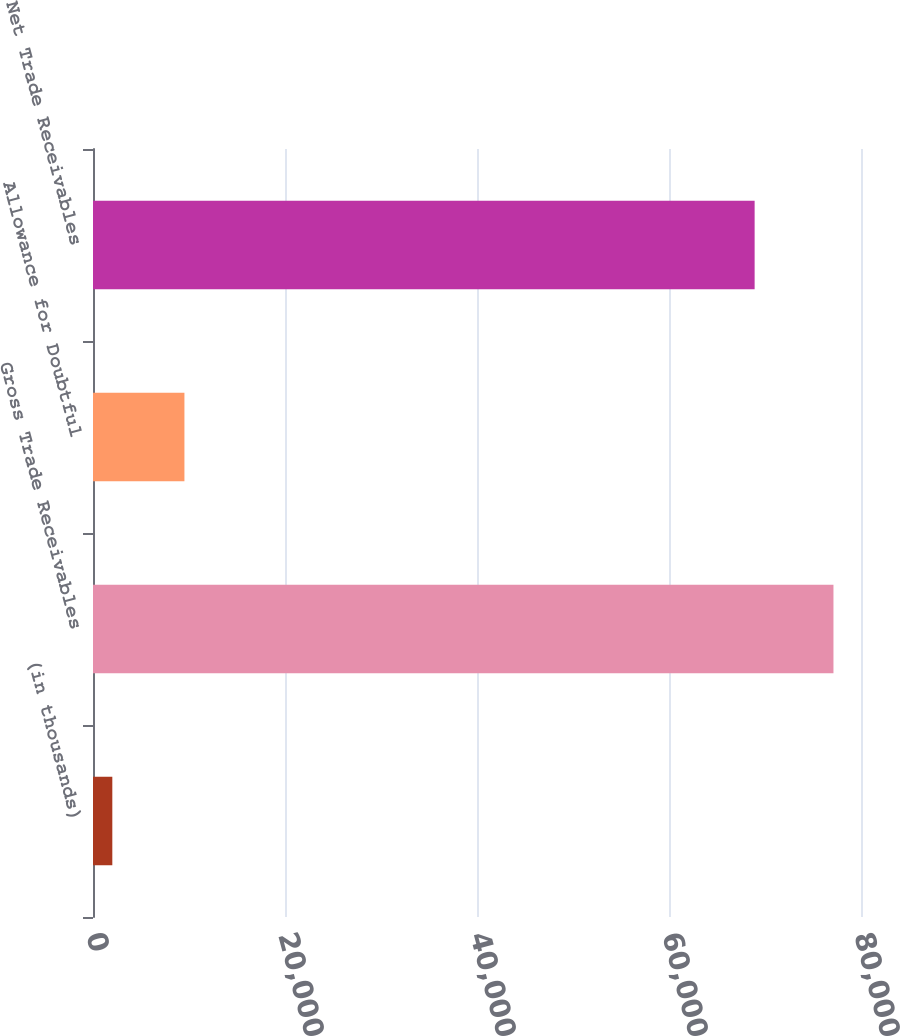<chart> <loc_0><loc_0><loc_500><loc_500><bar_chart><fcel>(in thousands)<fcel>Gross Trade Receivables<fcel>Allowance for Doubtful<fcel>Net Trade Receivables<nl><fcel>2012<fcel>77131<fcel>9523.9<fcel>68920<nl></chart> 